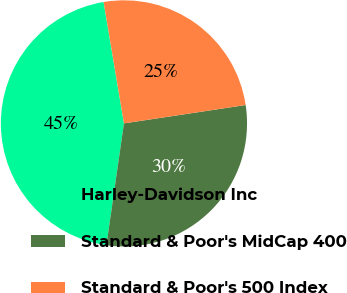<chart> <loc_0><loc_0><loc_500><loc_500><pie_chart><fcel>Harley-Davidson Inc<fcel>Standard & Poor's MidCap 400<fcel>Standard & Poor's 500 Index<nl><fcel>45.08%<fcel>29.66%<fcel>25.26%<nl></chart> 